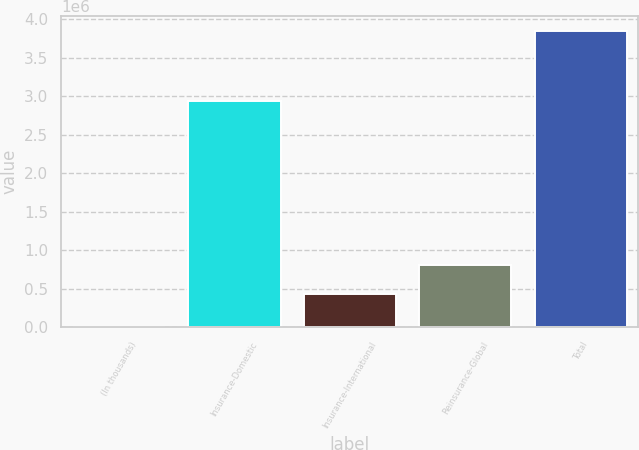Convert chart to OTSL. <chart><loc_0><loc_0><loc_500><loc_500><bar_chart><fcel>(In thousands)<fcel>Insurance-Domestic<fcel>Insurance-International<fcel>Reinsurance-Global<fcel>Total<nl><fcel>2010<fcel>2.93822e+06<fcel>430252<fcel>815144<fcel>3.85093e+06<nl></chart> 